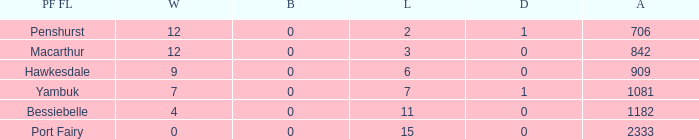How many wins for Port Fairy and against more than 2333? None. 